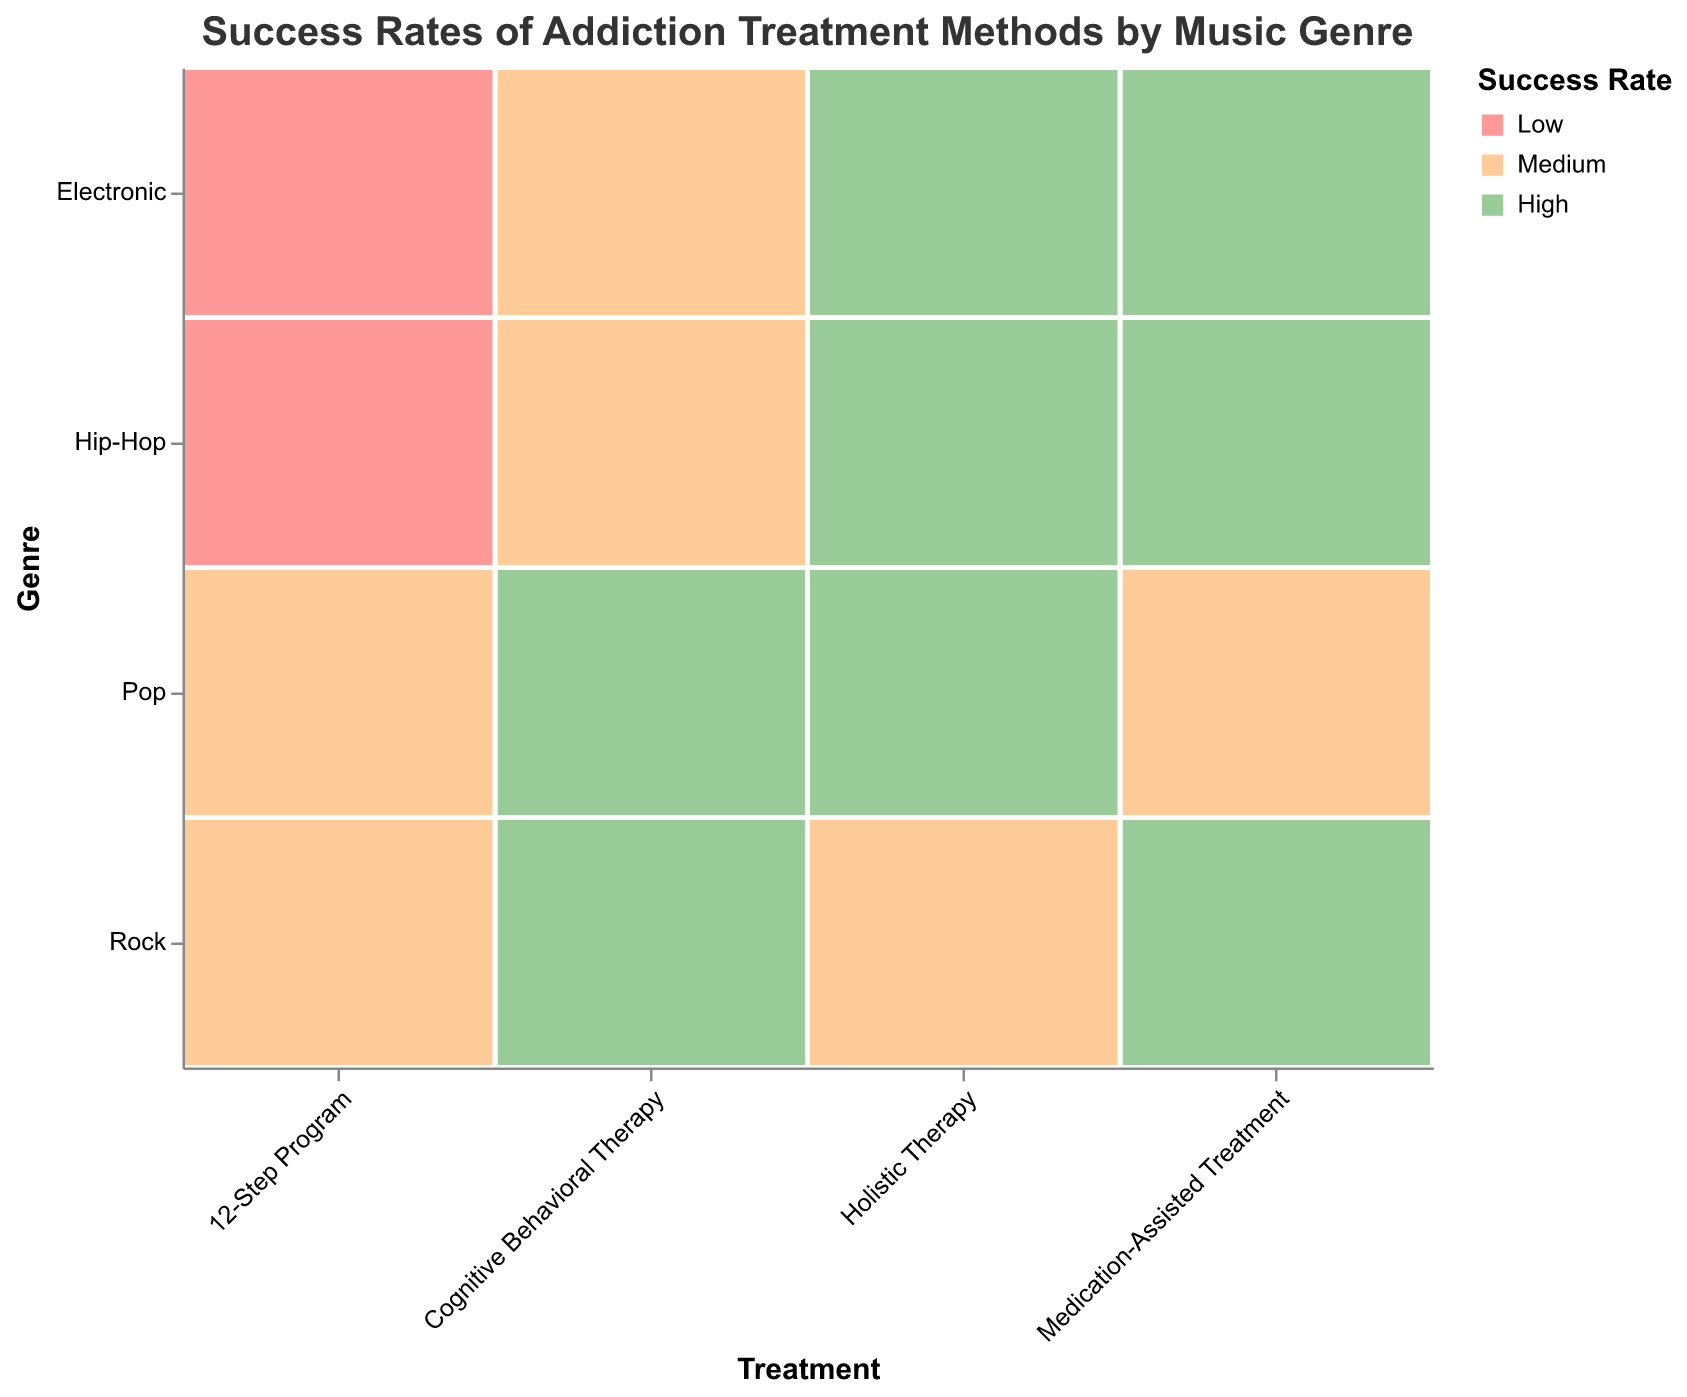How many genres have a high success rate with Cognitive Behavioral Therapy? Look at the rows representing Cognitive Behavioral Therapy and count the cells colored for high success rate, which is usually indicated in green.
Answer: 2 Which treatment method has the highest success rate for Hip-Hop? Compare the success rates for Hip-Hop across all treatment methods and identify which one is marked as "High" (indicated by green color).
Answer: Medication-Assisted Treatment How many success rates are medium for Electronic genre? Examine the Electronic row and count the number of cells colored for medium success rate, typically indicated by orange color.
Answer: 2 Is the success rate higher for Medication-Assisted Treatment or 12-Step Program in the Rock genre? Look at the cells where Rock intersects with Medication-Assisted Treatment and 12-Step Program. Compare their success rates, typically identified by their colors.
Answer: Medication-Assisted Treatment What is the total count of artists surveyed who underwent Holistic Therapy? Sum the counts of all cells under the Holistic Therapy treatment method. (Rock: 32, Hip-Hop: 40, Pop: 45, Electronic: 39) = 32 + 40 + 45 + 39
Answer: 156 Which genre has the lowest success rate with 12-Step Program? Look at the cells under the 12-Step Program and the genre column, then identify which genre has a cell indicating "Low" success rate (typically red).
Answer: Hip-Hop What is the count difference between high success rates for Rock and Pop genres? Identify the count numbers for high success rates in Rock (Cognitive Behavioral Therapy 45, Medication-Assisted Treatment 48) and Pop (Cognitive Behavioral Therapy 52, Holistic Therapy 45). Calculate the differences. 45 + 48 = 93, 52 + 45 = 97, so 97 - 93
Answer: 4 Which combination of treatment and genre has the highest count of artists surveyed? Look at all combinations and identify the one with the largest count number.
Answer: Cognitive Behavioral Therapy, Pop How many treatment methods provide medium success rates for the Pop genre? Check the cells corresponding to the Pop genre and count how many are marked as medium success rate (colored orange).
Answer: 2 Is Cognitive Behavioral Therapy more effective (high success rate) than Holistic Therapy across all genres? Compare the high success rate cells for Cognitive Behavioral Therapy and Holistic Therapy across all genres and count the occurrences.
Answer: No 